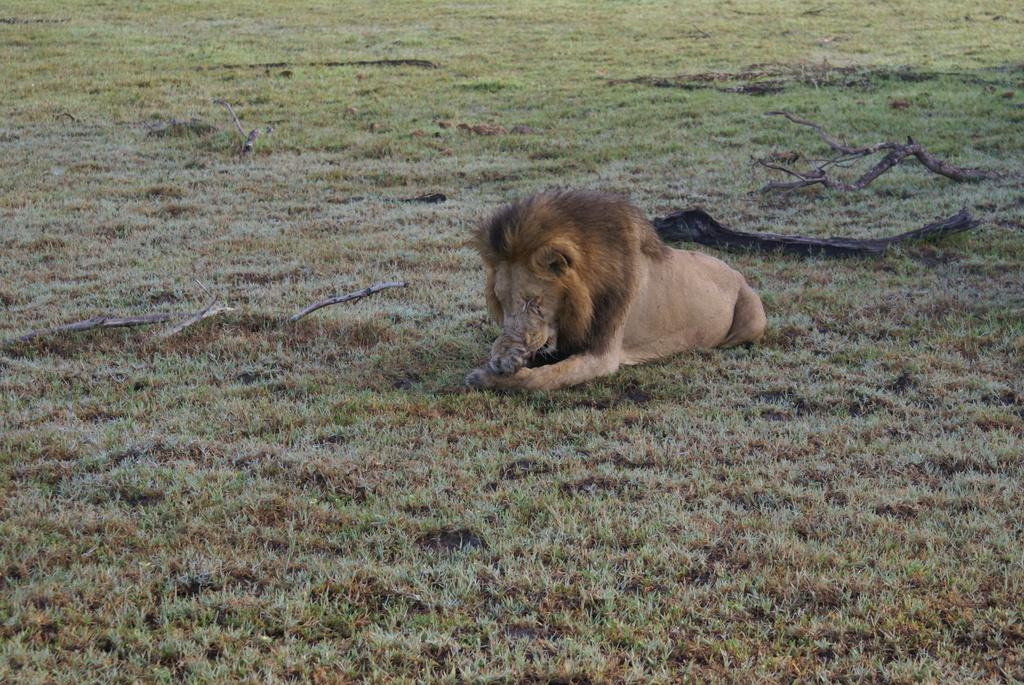What animal is in the picture? There is a lion in the picture. What position is the lion in? The lion is sitting on the floor. What type of vegetation is present in the picture? There is grass in the picture. What else can be found on the floor in the picture? There are twigs on the floor in the picture. What type of paper is the lion holding in its mouth? There is no paper present in the image; the lion is not holding anything in its mouth. 